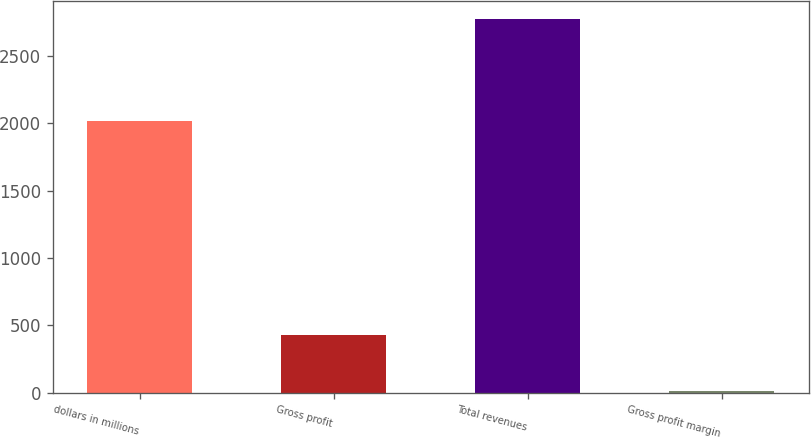Convert chart to OTSL. <chart><loc_0><loc_0><loc_500><loc_500><bar_chart><fcel>dollars in millions<fcel>Gross profit<fcel>Total revenues<fcel>Gross profit margin<nl><fcel>2013<fcel>426.9<fcel>2770.7<fcel>15.4<nl></chart> 